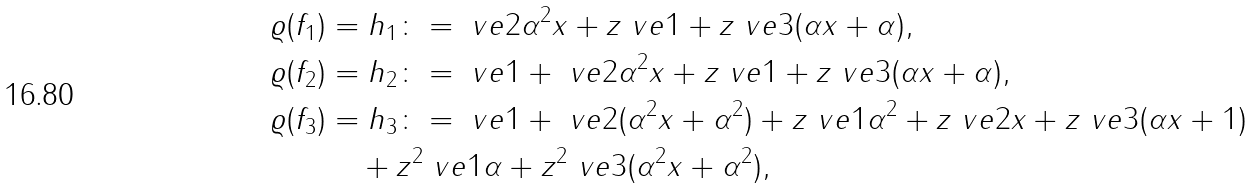<formula> <loc_0><loc_0><loc_500><loc_500>\varrho ( f _ { 1 } ) & = h _ { 1 } \colon = \ v e { 2 } \alpha ^ { 2 } x + z \ v e { 1 } + z \ v e { 3 } ( \alpha x + \alpha ) , \\ \varrho ( f _ { 2 } ) & = h _ { 2 } \colon = \ v e { 1 } + \ v e { 2 } \alpha ^ { 2 } x + z \ v e { 1 } + z \ v e { 3 } ( \alpha x + \alpha ) , \\ \varrho ( f _ { 3 } ) & = h _ { 3 } \colon = \ v e { 1 } + \ v e { 2 } ( \alpha ^ { 2 } x + \alpha ^ { 2 } ) + z \ v e { 1 } \alpha ^ { 2 } + z \ v e { 2 } x + z \ v e { 3 } ( \alpha x + 1 ) \\ & \quad + z ^ { 2 } \ v e { 1 } \alpha + z ^ { 2 } \ v e { 3 } ( \alpha ^ { 2 } x + \alpha ^ { 2 } ) ,</formula> 